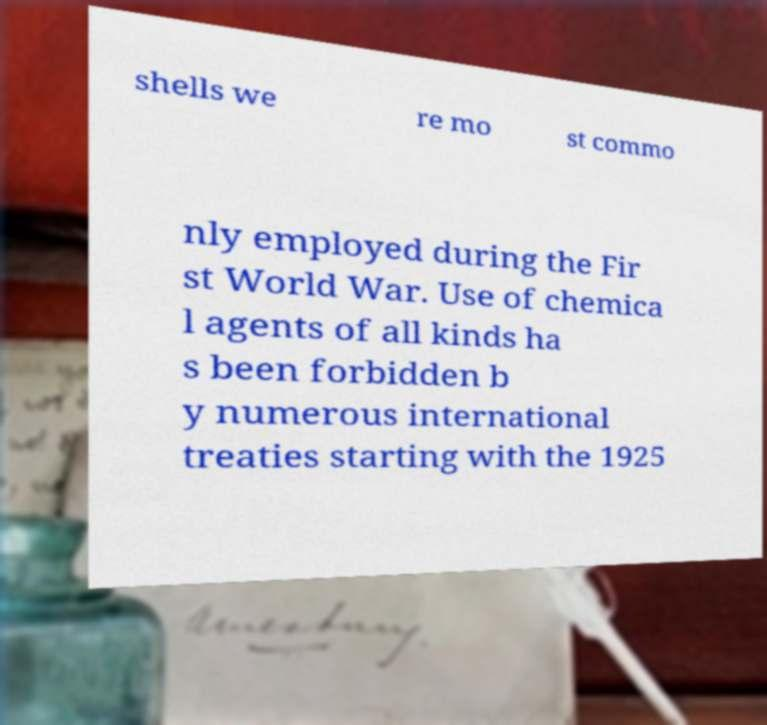Can you accurately transcribe the text from the provided image for me? shells we re mo st commo nly employed during the Fir st World War. Use of chemica l agents of all kinds ha s been forbidden b y numerous international treaties starting with the 1925 